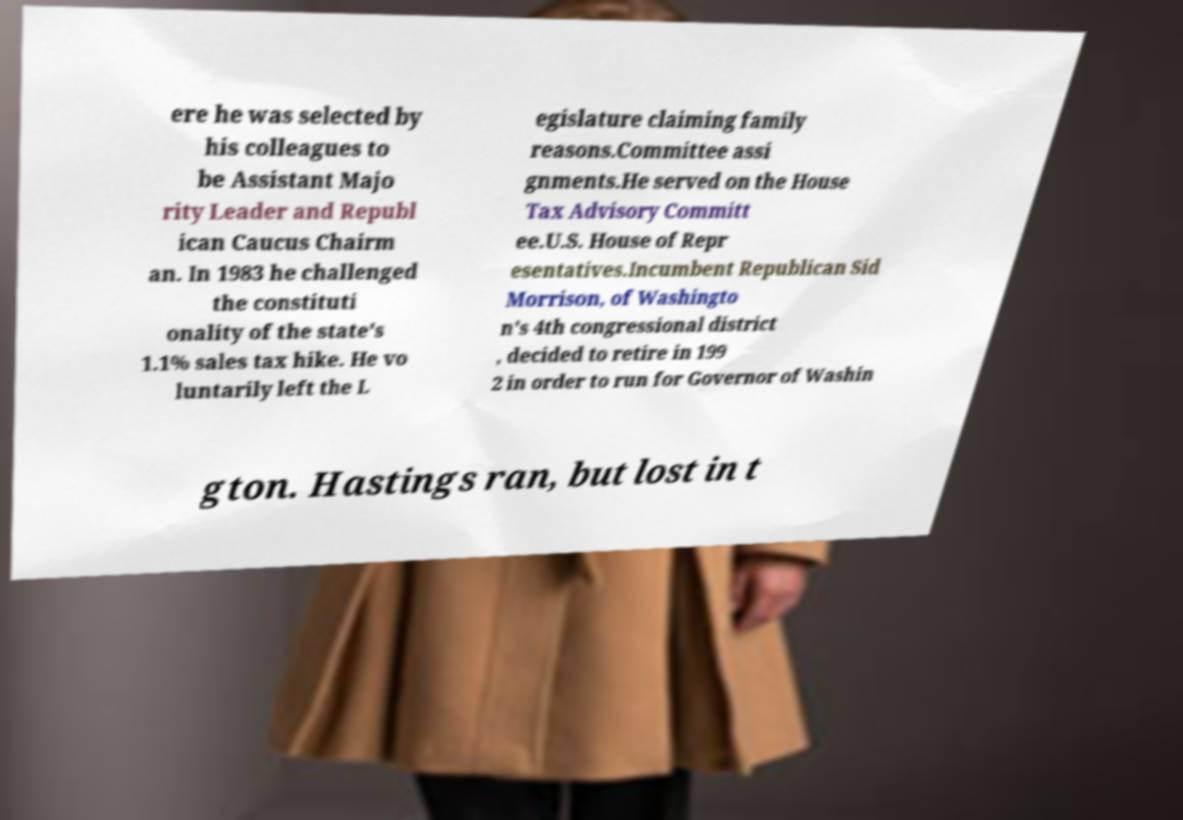I need the written content from this picture converted into text. Can you do that? ere he was selected by his colleagues to be Assistant Majo rity Leader and Republ ican Caucus Chairm an. In 1983 he challenged the constituti onality of the state's 1.1% sales tax hike. He vo luntarily left the L egislature claiming family reasons.Committee assi gnments.He served on the House Tax Advisory Committ ee.U.S. House of Repr esentatives.Incumbent Republican Sid Morrison, of Washingto n's 4th congressional district , decided to retire in 199 2 in order to run for Governor of Washin gton. Hastings ran, but lost in t 